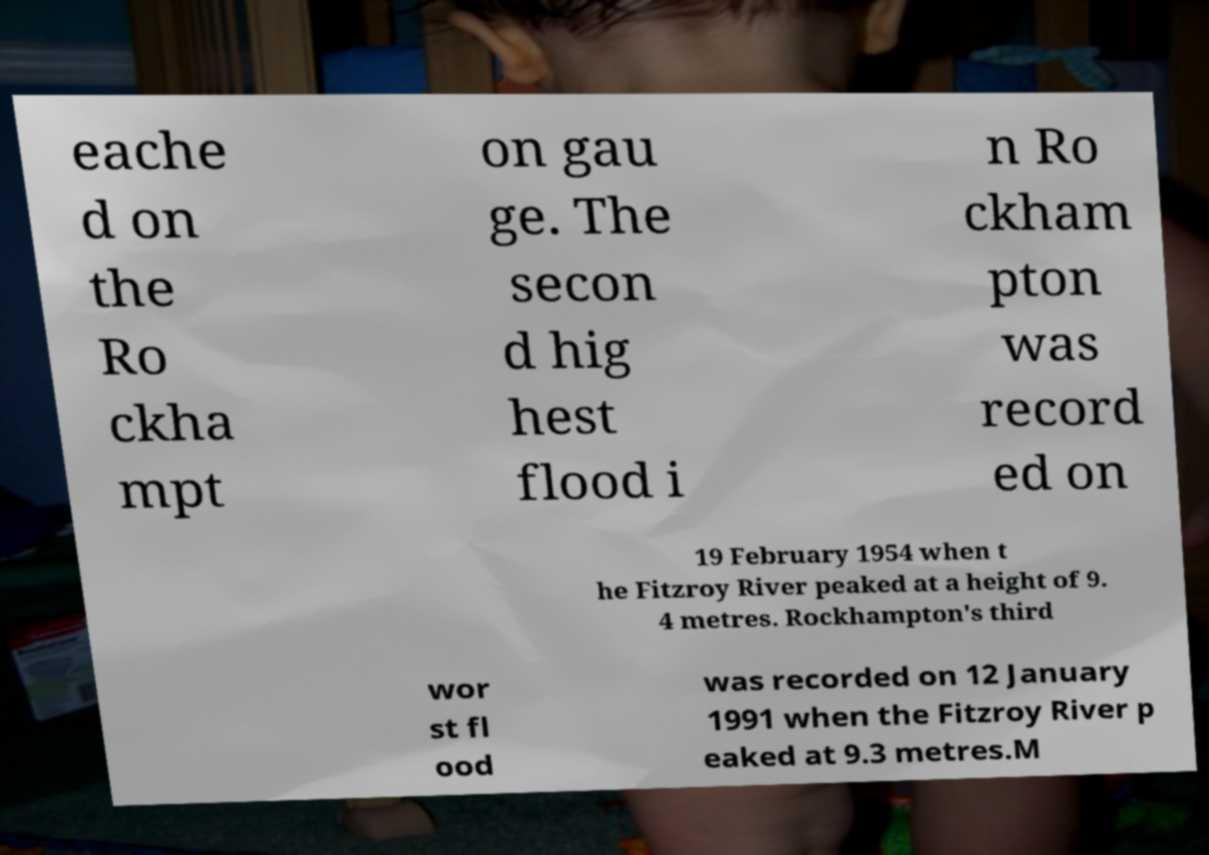Please identify and transcribe the text found in this image. eache d on the Ro ckha mpt on gau ge. The secon d hig hest flood i n Ro ckham pton was record ed on 19 February 1954 when t he Fitzroy River peaked at a height of 9. 4 metres. Rockhampton's third wor st fl ood was recorded on 12 January 1991 when the Fitzroy River p eaked at 9.3 metres.M 